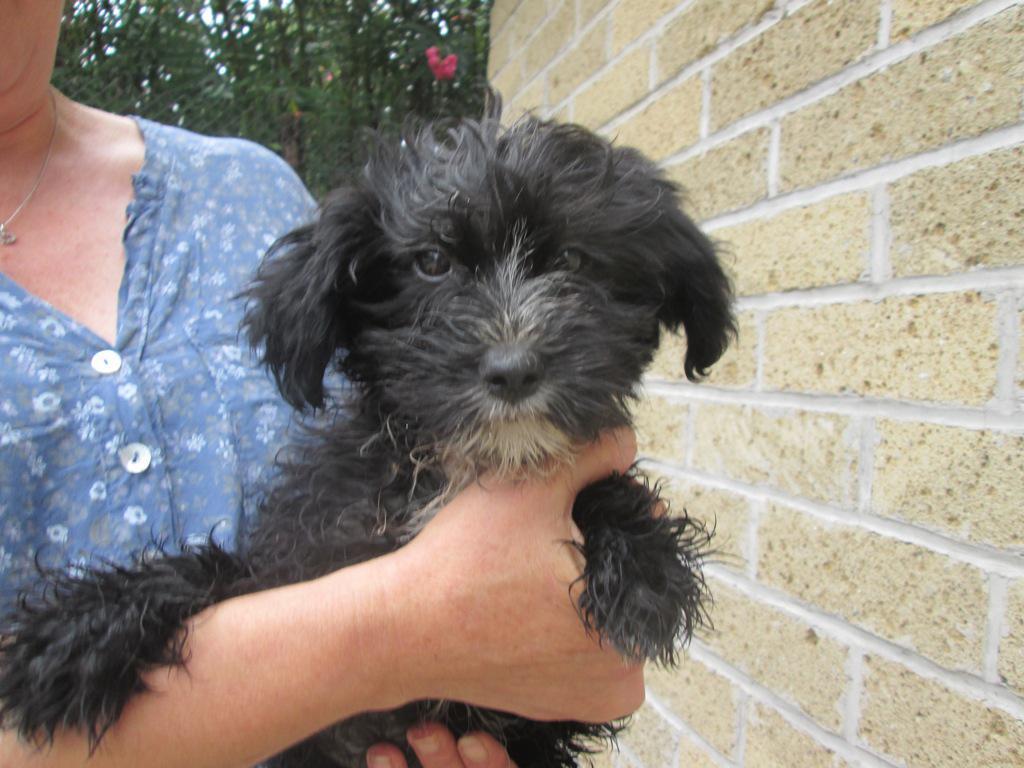Describe this image in one or two sentences. In this image we can see one black dog, some trees in the background, one wall on the right side of the image, one tree with red flower, one person holding a dog and truncated on the left side of the image. 